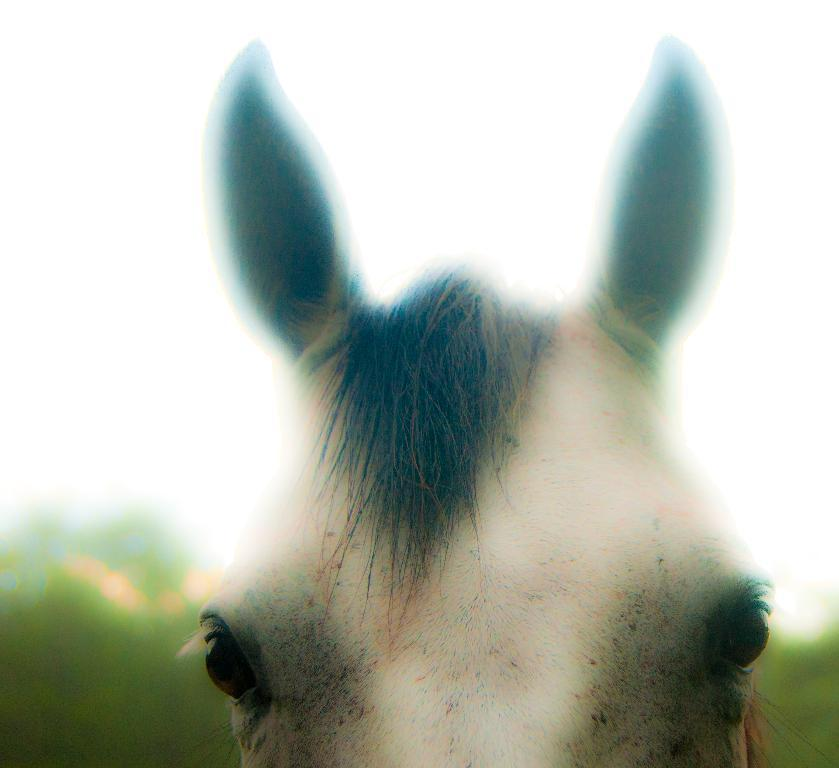What is the main subject of the picture? There is a horse in the picture. What can be seen in the background of the picture? There are trees and the sky visible in the background of the picture. How would you describe the quality of the image? The image is blurry. What type of army is depicted in the picture? There is no army present in the picture; it features a horse and a background with trees and the sky. What emotion does the horse display in the picture? The horse's emotions cannot be determined from the image, as it is a photograph and not a representation of the horse's feelings. 